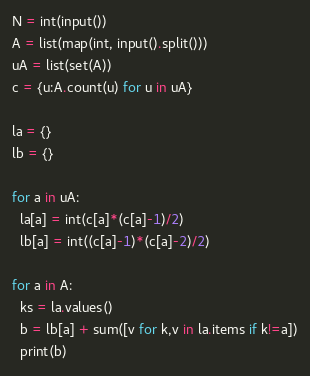Convert code to text. <code><loc_0><loc_0><loc_500><loc_500><_Python_>N = int(input())
A = list(map(int, input().split()))
uA = list(set(A))
c = {u:A.count(u) for u in uA}
 
la = {}
lb = {}
 
for a in uA:
  la[a] = int(c[a]*(c[a]-1)/2)
  lb[a] = int((c[a]-1)*(c[a]-2)/2)
  
for a in A:
  ks = la.values()
  b = lb[a] + sum([v for k,v in la.items if k!=a])
  print(b)</code> 